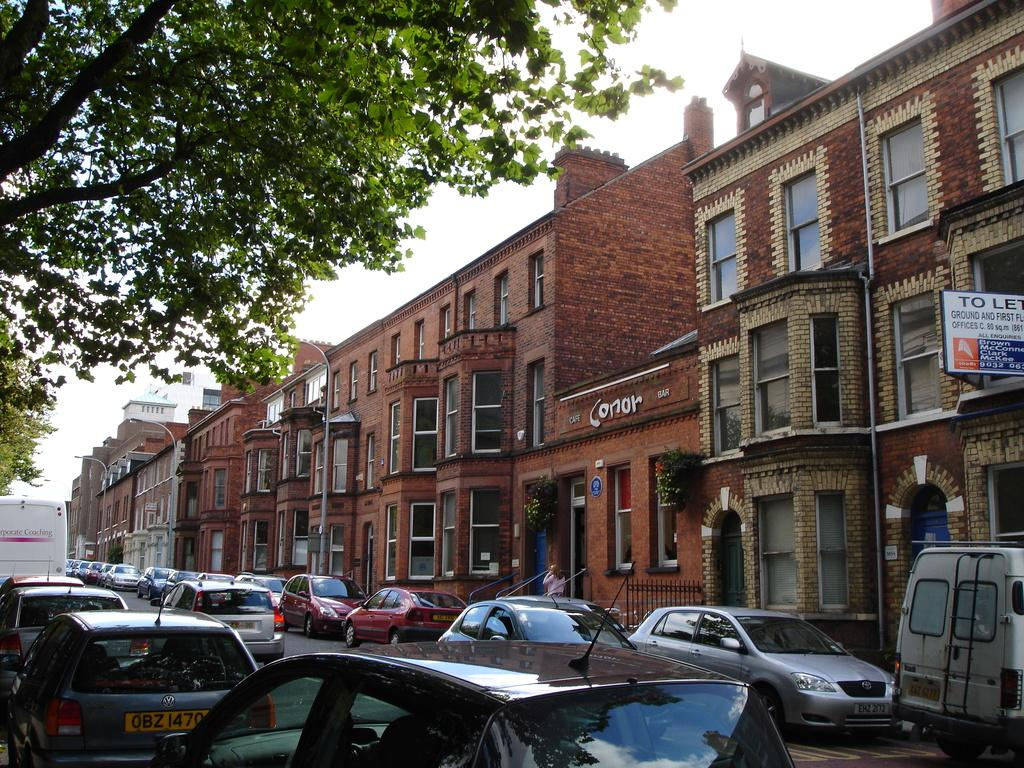<image>
Share a concise interpretation of the image provided. a sign on top of a building that says Conor on it 